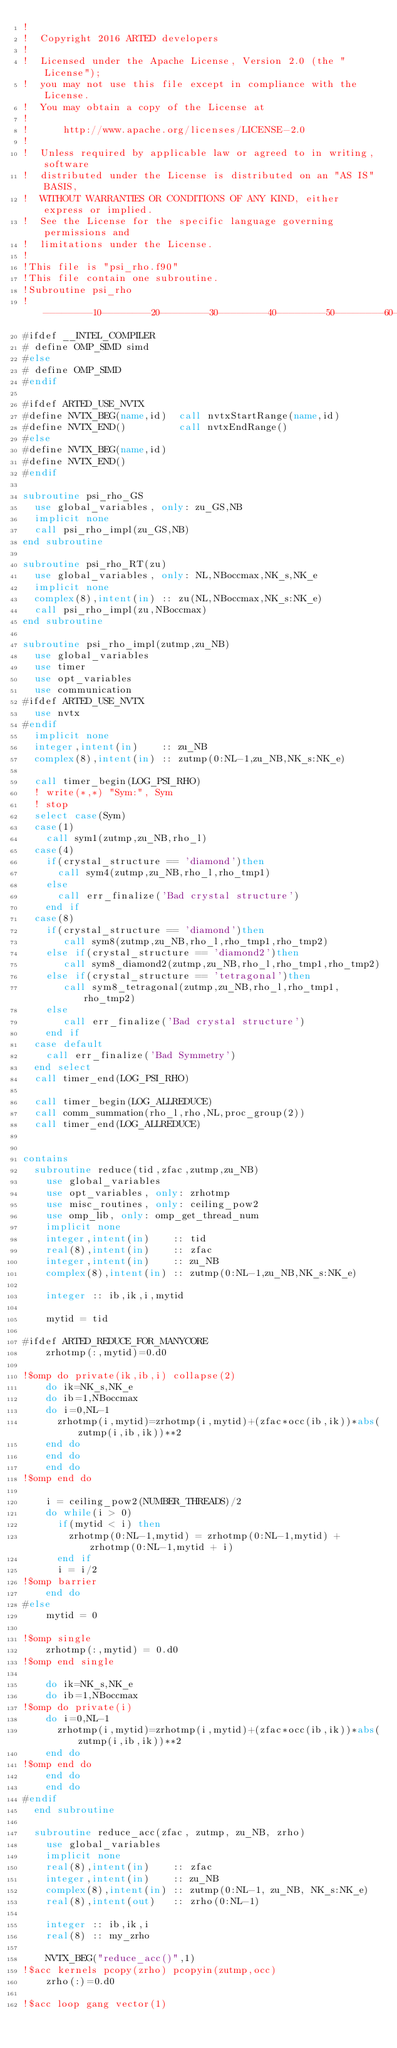Convert code to text. <code><loc_0><loc_0><loc_500><loc_500><_FORTRAN_>!
!  Copyright 2016 ARTED developers
!
!  Licensed under the Apache License, Version 2.0 (the "License");
!  you may not use this file except in compliance with the License.
!  You may obtain a copy of the License at
!
!      http://www.apache.org/licenses/LICENSE-2.0
!
!  Unless required by applicable law or agreed to in writing, software
!  distributed under the License is distributed on an "AS IS" BASIS,
!  WITHOUT WARRANTIES OR CONDITIONS OF ANY KIND, either express or implied.
!  See the License for the specific language governing permissions and
!  limitations under the License.
!
!This file is "psi_rho.f90"
!This file contain one subroutine.
!Subroutine psi_rho
!--------10--------20--------30--------40--------50--------60--------70--------80--------90--------100-------110-------120--------130
#ifdef __INTEL_COMPILER
# define OMP_SIMD simd
#else
# define OMP_SIMD
#endif

#ifdef ARTED_USE_NVTX
#define NVTX_BEG(name,id)  call nvtxStartRange(name,id)
#define NVTX_END()         call nvtxEndRange()
#else
#define NVTX_BEG(name,id)
#define NVTX_END()
#endif

subroutine psi_rho_GS
  use global_variables, only: zu_GS,NB
  implicit none
  call psi_rho_impl(zu_GS,NB)
end subroutine

subroutine psi_rho_RT(zu)
  use global_variables, only: NL,NBoccmax,NK_s,NK_e
  implicit none
  complex(8),intent(in) :: zu(NL,NBoccmax,NK_s:NK_e)
  call psi_rho_impl(zu,NBoccmax)
end subroutine

subroutine psi_rho_impl(zutmp,zu_NB)
  use global_variables
  use timer
  use opt_variables
  use communication
#ifdef ARTED_USE_NVTX
  use nvtx
#endif
  implicit none
  integer,intent(in)    :: zu_NB
  complex(8),intent(in) :: zutmp(0:NL-1,zu_NB,NK_s:NK_e)

  call timer_begin(LOG_PSI_RHO)
  ! write(*,*) "Sym:", Sym
  ! stop
  select case(Sym)
  case(1)
    call sym1(zutmp,zu_NB,rho_l)
  case(4)
    if(crystal_structure == 'diamond')then
      call sym4(zutmp,zu_NB,rho_l,rho_tmp1)
    else
      call err_finalize('Bad crystal structure')
    end if
  case(8)
    if(crystal_structure == 'diamond')then
       call sym8(zutmp,zu_NB,rho_l,rho_tmp1,rho_tmp2)
    else if(crystal_structure == 'diamond2')then
       call sym8_diamond2(zutmp,zu_NB,rho_l,rho_tmp1,rho_tmp2)
    else if(crystal_structure == 'tetragonal')then
       call sym8_tetragonal(zutmp,zu_NB,rho_l,rho_tmp1,rho_tmp2)
    else
       call err_finalize('Bad crystal structure')
    end if
  case default
    call err_finalize('Bad Symmetry')
  end select
  call timer_end(LOG_PSI_RHO)

  call timer_begin(LOG_ALLREDUCE)
  call comm_summation(rho_l,rho,NL,proc_group(2))
  call timer_end(LOG_ALLREDUCE)


contains
  subroutine reduce(tid,zfac,zutmp,zu_NB)
    use global_variables
    use opt_variables, only: zrhotmp
    use misc_routines, only: ceiling_pow2
    use omp_lib, only: omp_get_thread_num
    implicit none
    integer,intent(in)    :: tid
    real(8),intent(in)    :: zfac
    integer,intent(in)    :: zu_NB
    complex(8),intent(in) :: zutmp(0:NL-1,zu_NB,NK_s:NK_e)

    integer :: ib,ik,i,mytid

    mytid = tid

#ifdef ARTED_REDUCE_FOR_MANYCORE
    zrhotmp(:,mytid)=0.d0

!$omp do private(ik,ib,i) collapse(2)
    do ik=NK_s,NK_e
    do ib=1,NBoccmax
    do i=0,NL-1
      zrhotmp(i,mytid)=zrhotmp(i,mytid)+(zfac*occ(ib,ik))*abs(zutmp(i,ib,ik))**2
    end do
    end do
    end do
!$omp end do

    i = ceiling_pow2(NUMBER_THREADS)/2
    do while(i > 0)
      if(mytid < i) then
        zrhotmp(0:NL-1,mytid) = zrhotmp(0:NL-1,mytid) + zrhotmp(0:NL-1,mytid + i)
      end if
      i = i/2
!$omp barrier
    end do
#else
    mytid = 0

!$omp single
    zrhotmp(:,mytid) = 0.d0
!$omp end single

    do ik=NK_s,NK_e
    do ib=1,NBoccmax
!$omp do private(i)
    do i=0,NL-1
      zrhotmp(i,mytid)=zrhotmp(i,mytid)+(zfac*occ(ib,ik))*abs(zutmp(i,ib,ik))**2
    end do
!$omp end do
    end do
    end do
#endif
  end subroutine

  subroutine reduce_acc(zfac, zutmp, zu_NB, zrho)
    use global_variables
    implicit none
    real(8),intent(in)    :: zfac
    integer,intent(in)    :: zu_NB
    complex(8),intent(in) :: zutmp(0:NL-1, zu_NB, NK_s:NK_e)
    real(8),intent(out)   :: zrho(0:NL-1)

    integer :: ib,ik,i
    real(8) :: my_zrho

    NVTX_BEG("reduce_acc()",1)
!$acc kernels pcopy(zrho) pcopyin(zutmp,occ)
    zrho(:)=0.d0

!$acc loop gang vector(1)</code> 